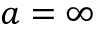Convert formula to latex. <formula><loc_0><loc_0><loc_500><loc_500>a = \infty</formula> 